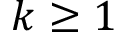Convert formula to latex. <formula><loc_0><loc_0><loc_500><loc_500>k \geq 1</formula> 